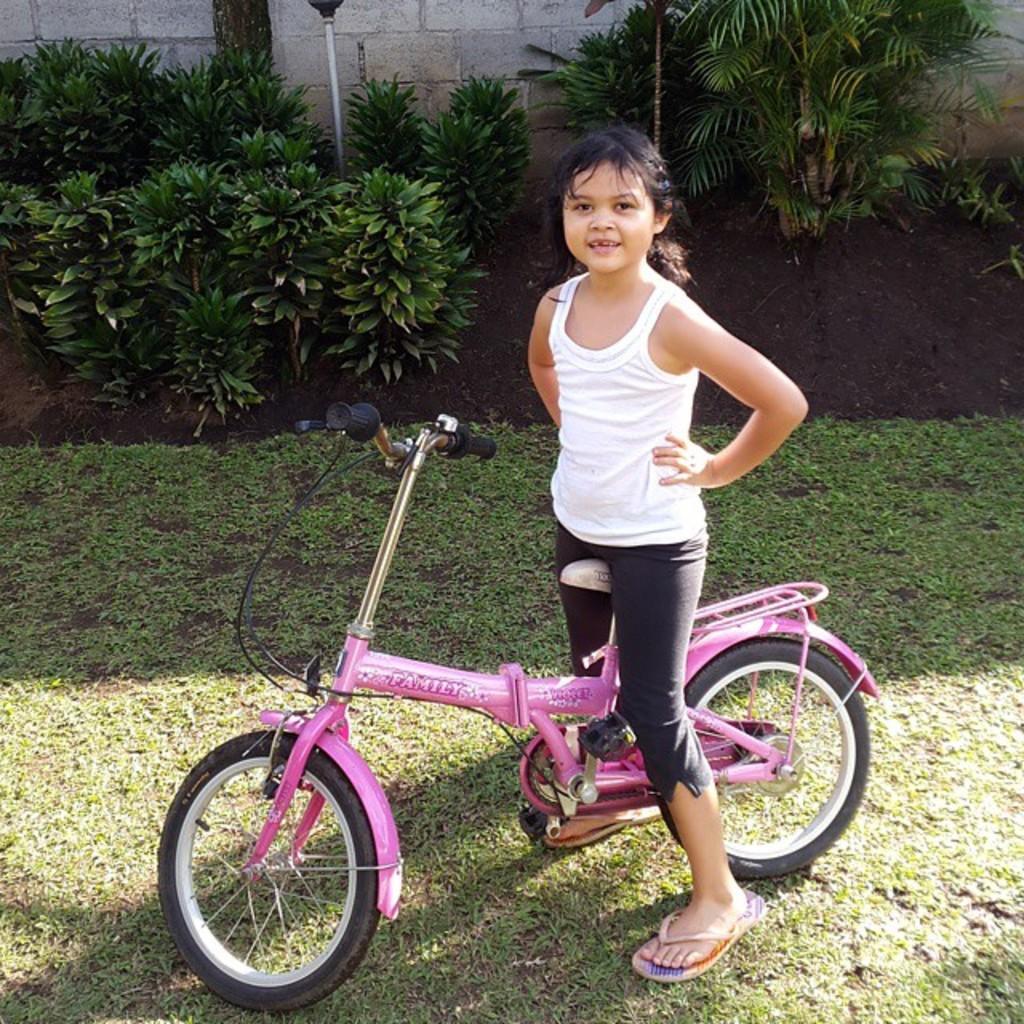In one or two sentences, can you explain what this image depicts? This picture is taken in the garden, In the middle there is a girl riding a bicycle which is in pink color, In the background there are some green color plants and there is a wall which is in ash color. 